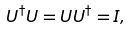<formula> <loc_0><loc_0><loc_500><loc_500>U ^ { \dagger } U = U U ^ { \dagger } = I ,</formula> 